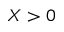<formula> <loc_0><loc_0><loc_500><loc_500>X > 0</formula> 